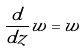<formula> <loc_0><loc_0><loc_500><loc_500>\frac { d } { d z } w = w</formula> 